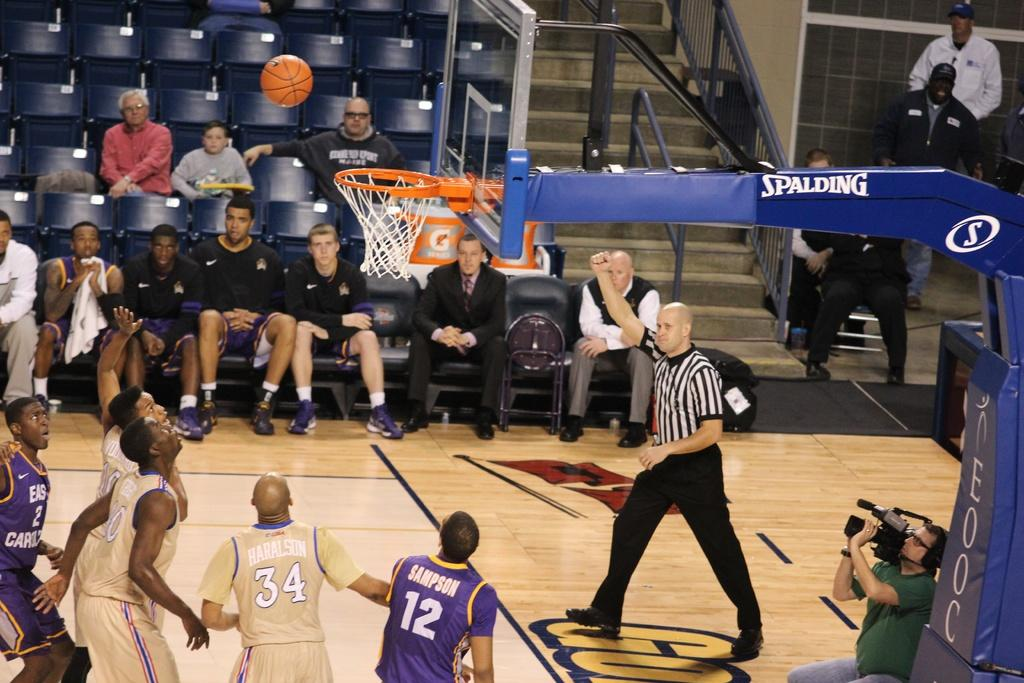Provide a one-sentence caption for the provided image. A basketball hoop labeled Spalding hangs over a game in progress. 